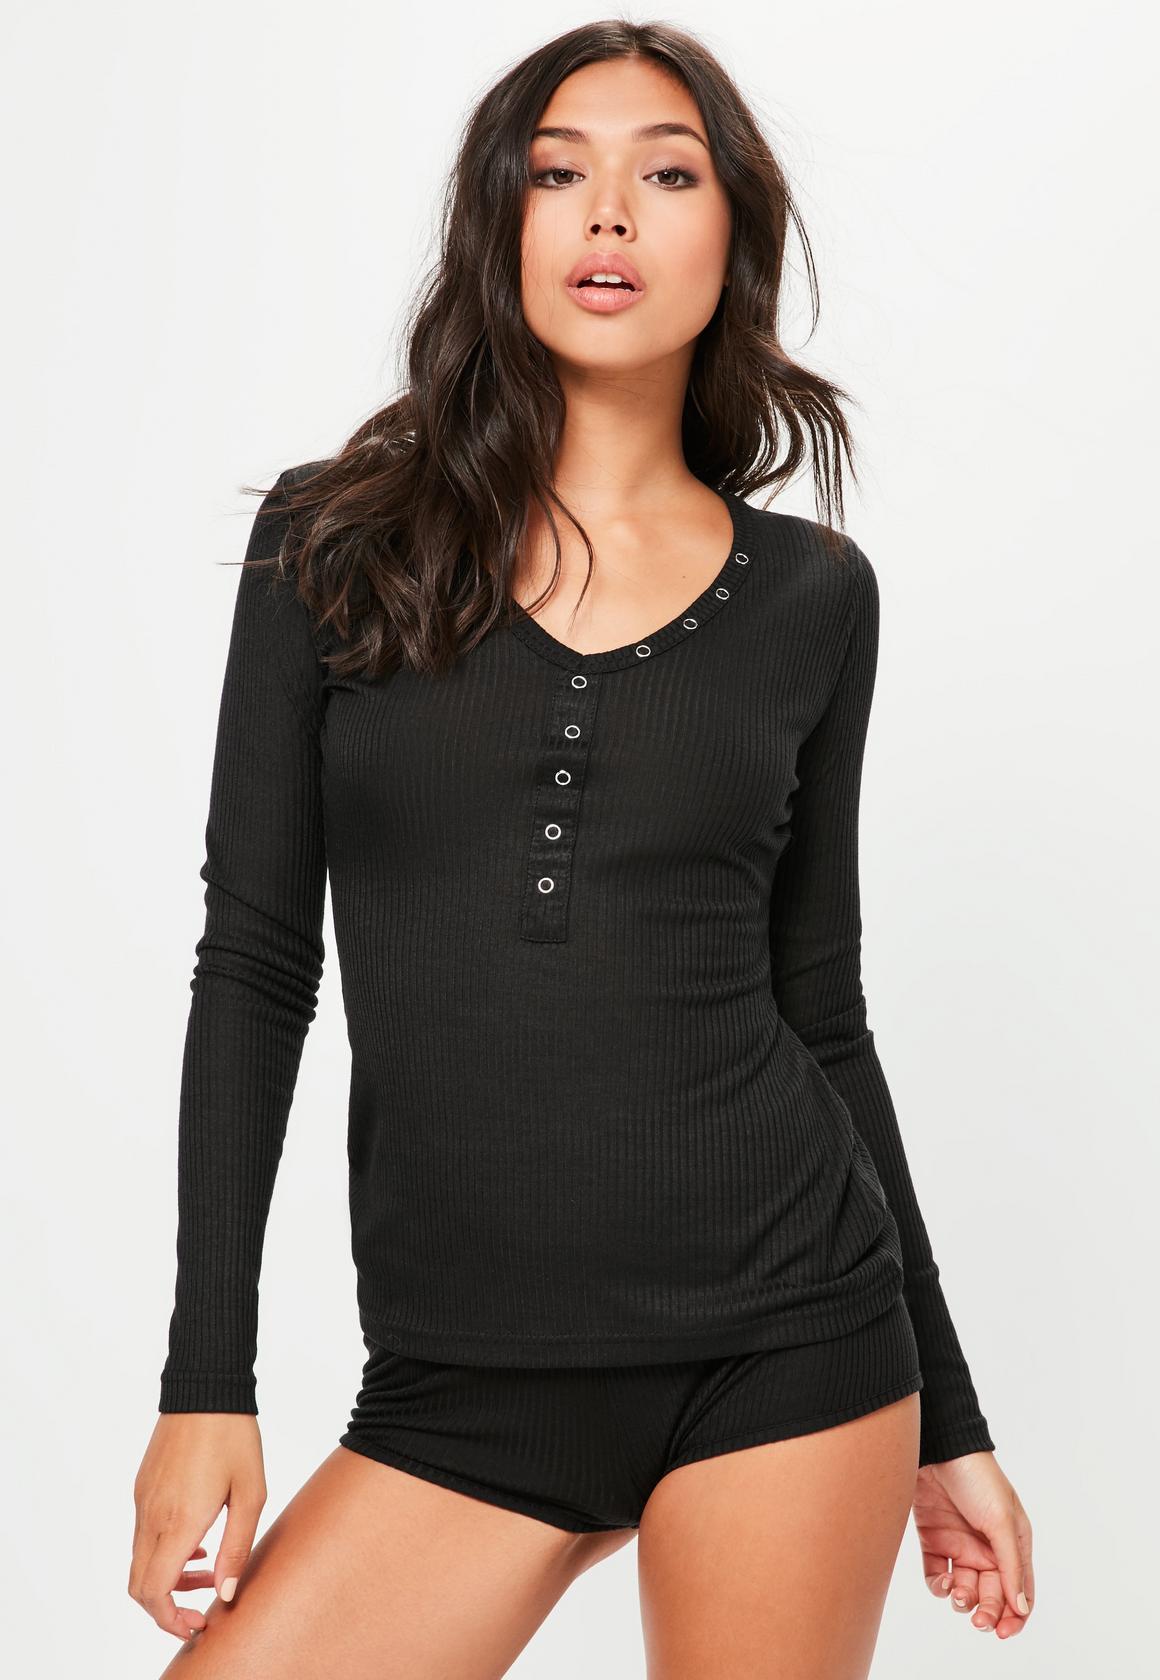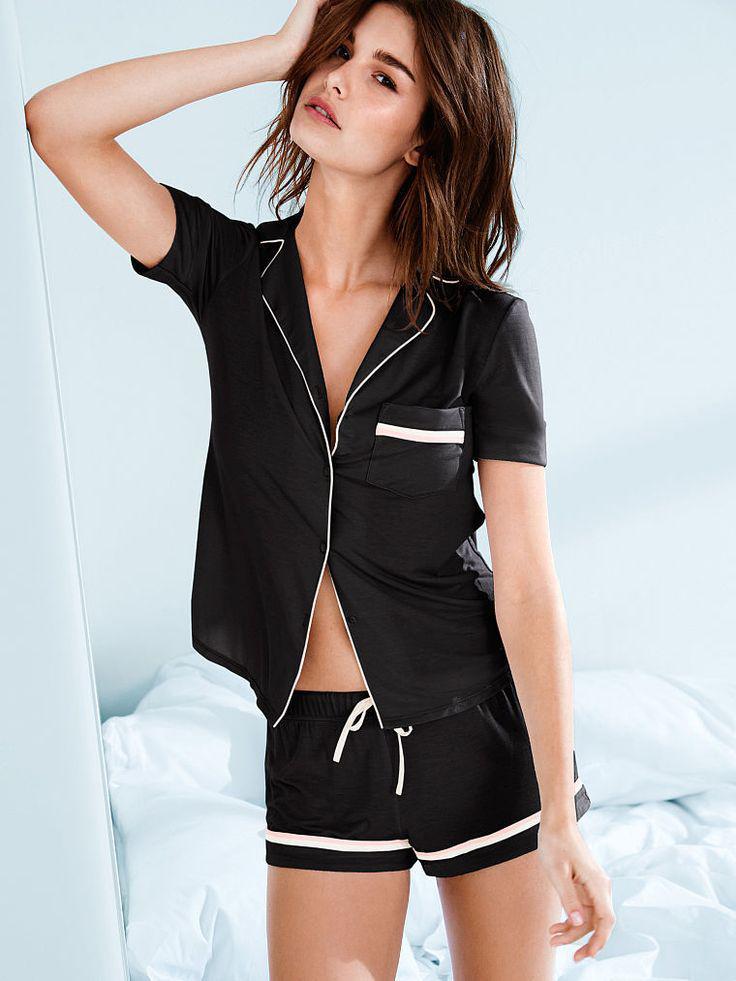The first image is the image on the left, the second image is the image on the right. Assess this claim about the two images: "One image shows a women wearing a night gown with a robe.". Correct or not? Answer yes or no. No. 